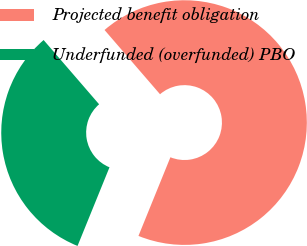<chart> <loc_0><loc_0><loc_500><loc_500><pie_chart><fcel>Projected benefit obligation<fcel>Underfunded (overfunded) PBO<nl><fcel>67.48%<fcel>32.52%<nl></chart> 